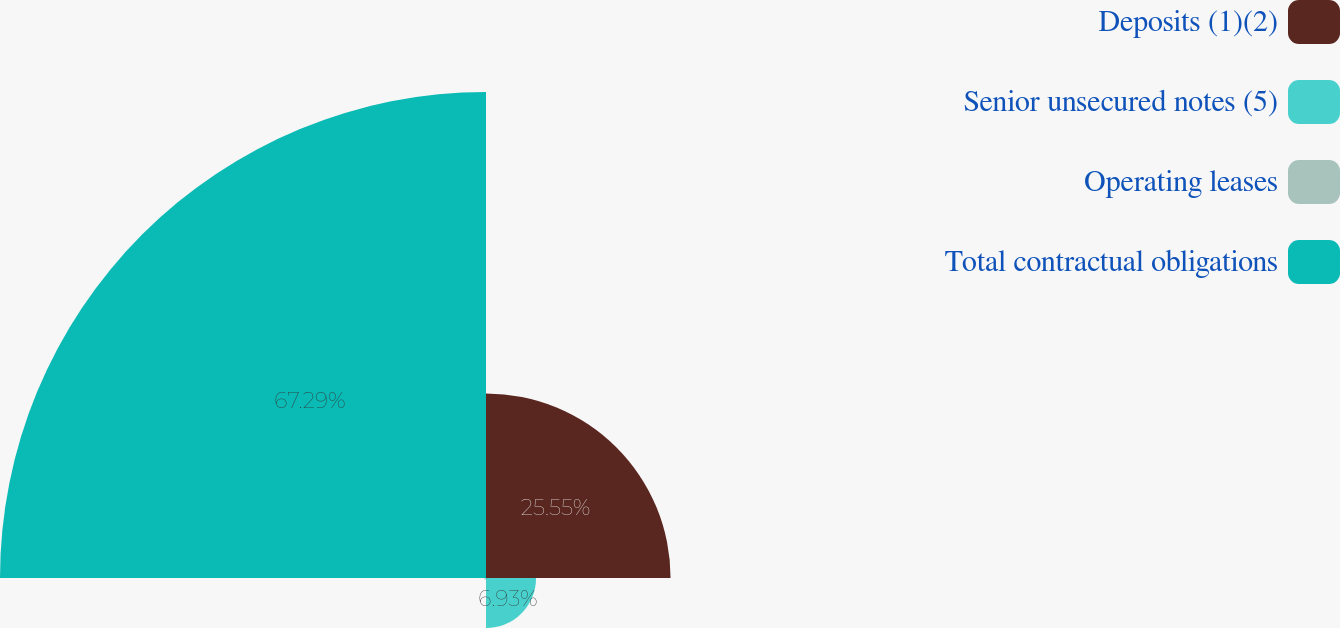Convert chart to OTSL. <chart><loc_0><loc_0><loc_500><loc_500><pie_chart><fcel>Deposits (1)(2)<fcel>Senior unsecured notes (5)<fcel>Operating leases<fcel>Total contractual obligations<nl><fcel>25.55%<fcel>6.93%<fcel>0.23%<fcel>67.28%<nl></chart> 